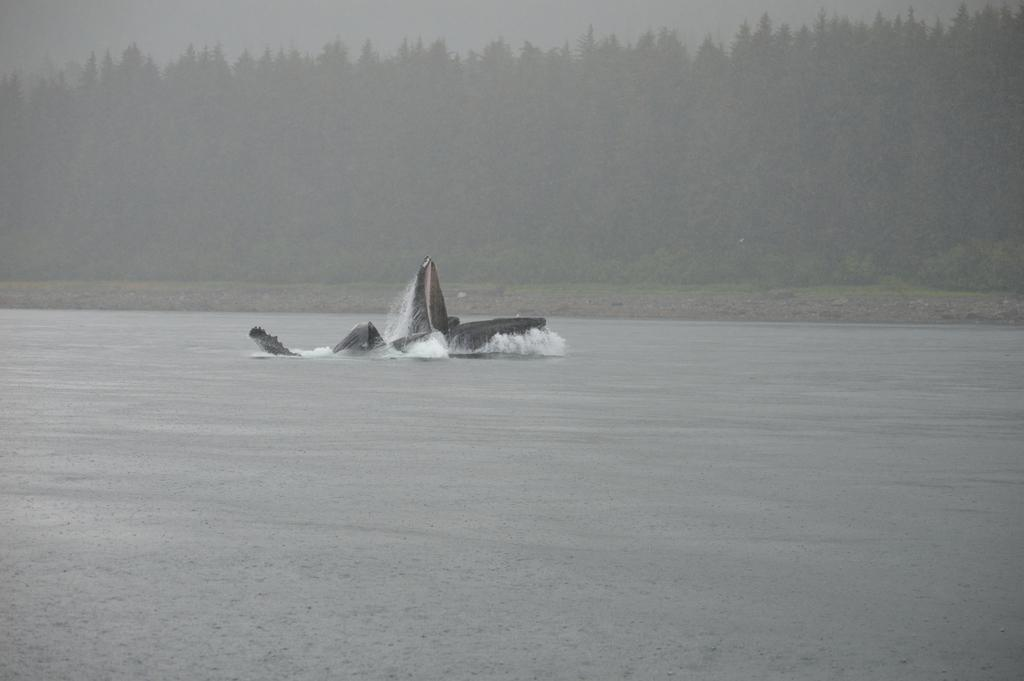What is the main subject of the image? The main subject of the image is a boat. What is the boat doing in the image? The boat is sailing in the water. Can you describe the water in the image? The water might be in a river, as suggested by the presence of trees in the background. What can be seen in the background of the image? There are trees in the background of the image. What type of scarf is the scarecrow wearing in the image? There is no scarecrow or scarf present in the image; it features a boat sailing in the water with trees in the background. How many train tracks can be seen in the image? There are no train tracks visible in the image. 